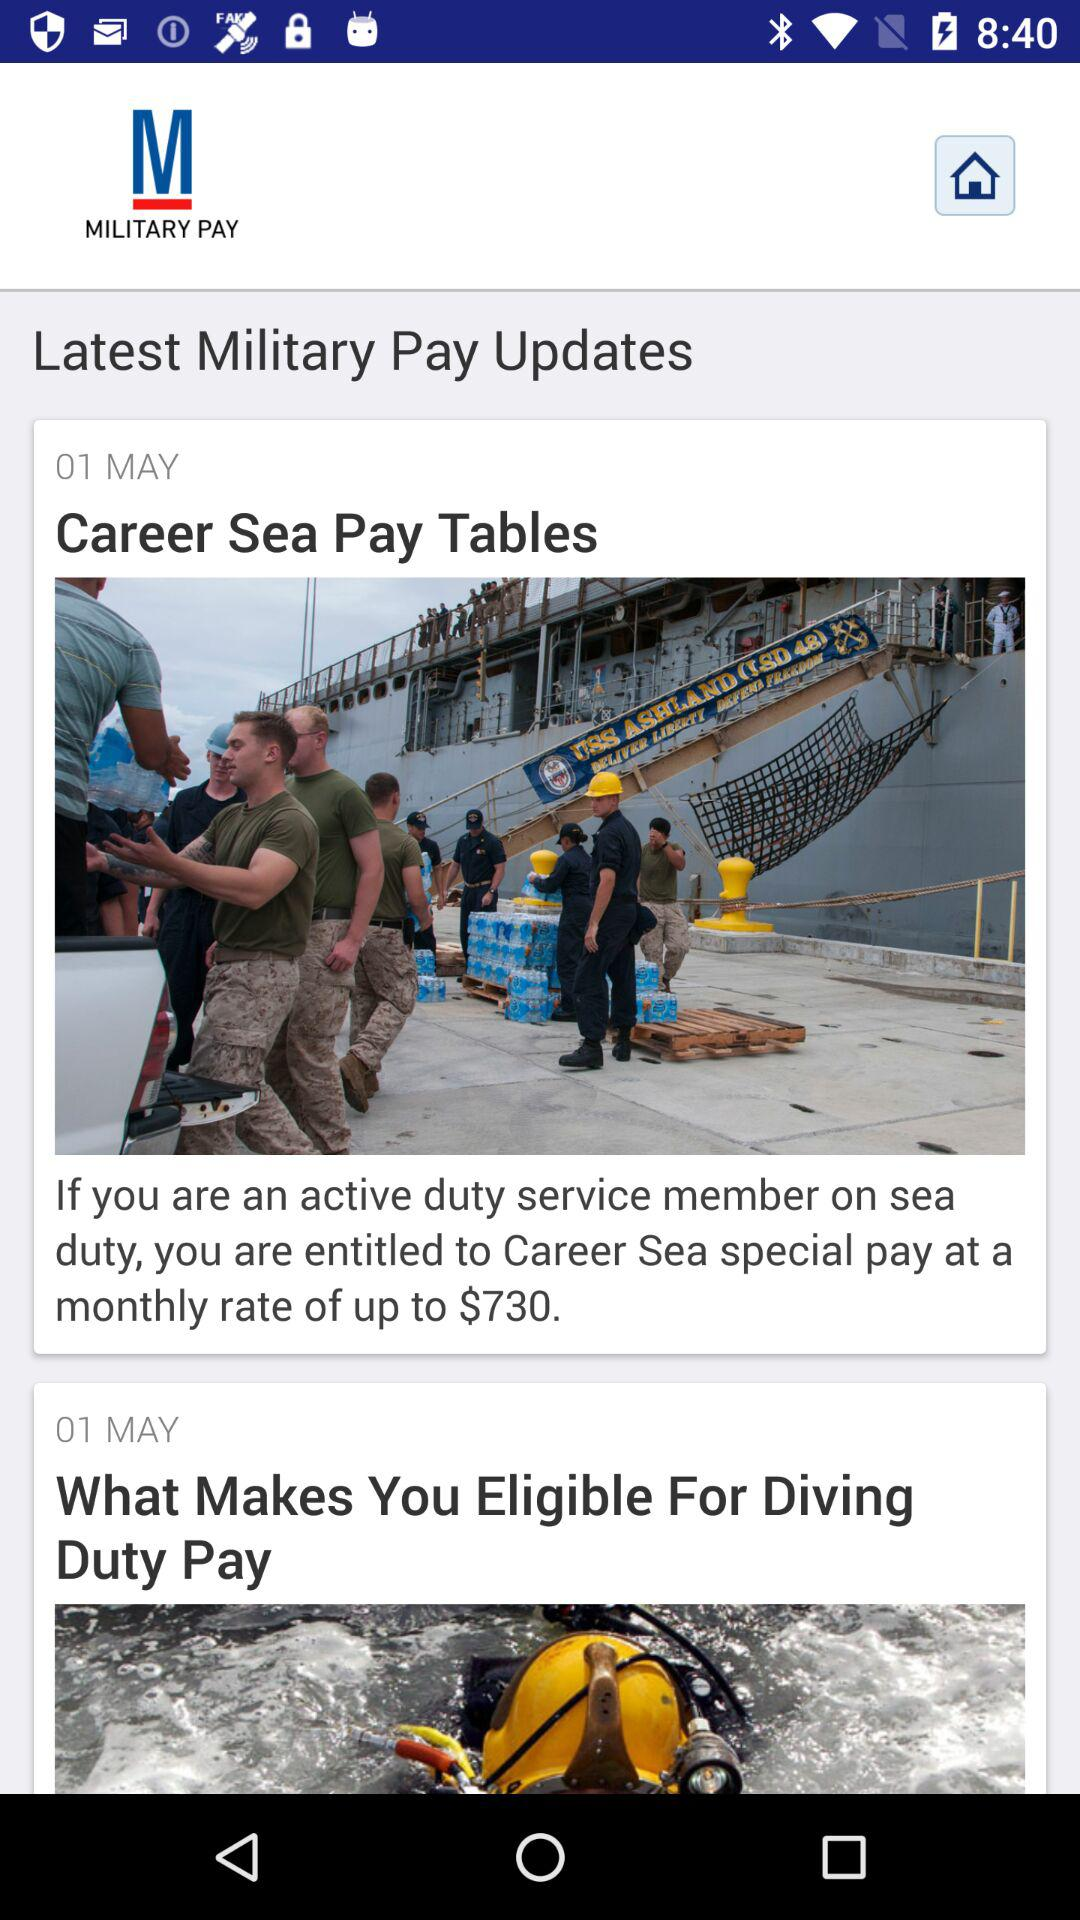Which requirements are listed to meet the eligibility of diving duty pay?
When the provided information is insufficient, respond with <no answer>. <no answer> 